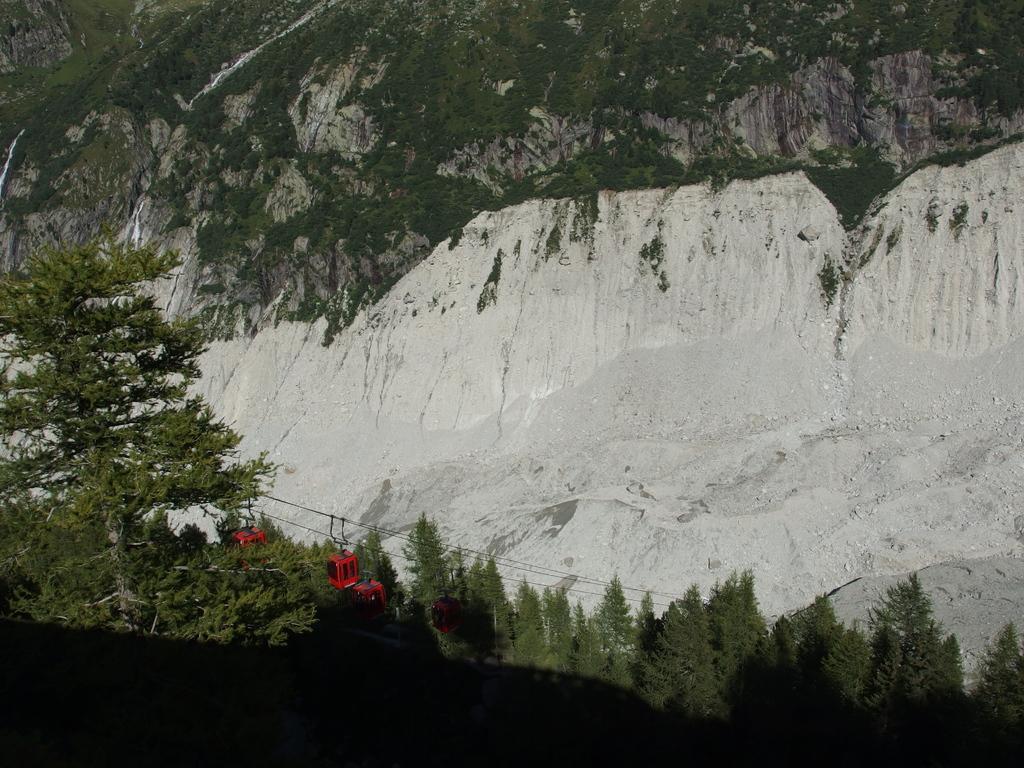Can you describe this image briefly? In this image at the bottom there are wires and cable cars and also we could see trees and mountains, at the bottom of the image there is shadow. 